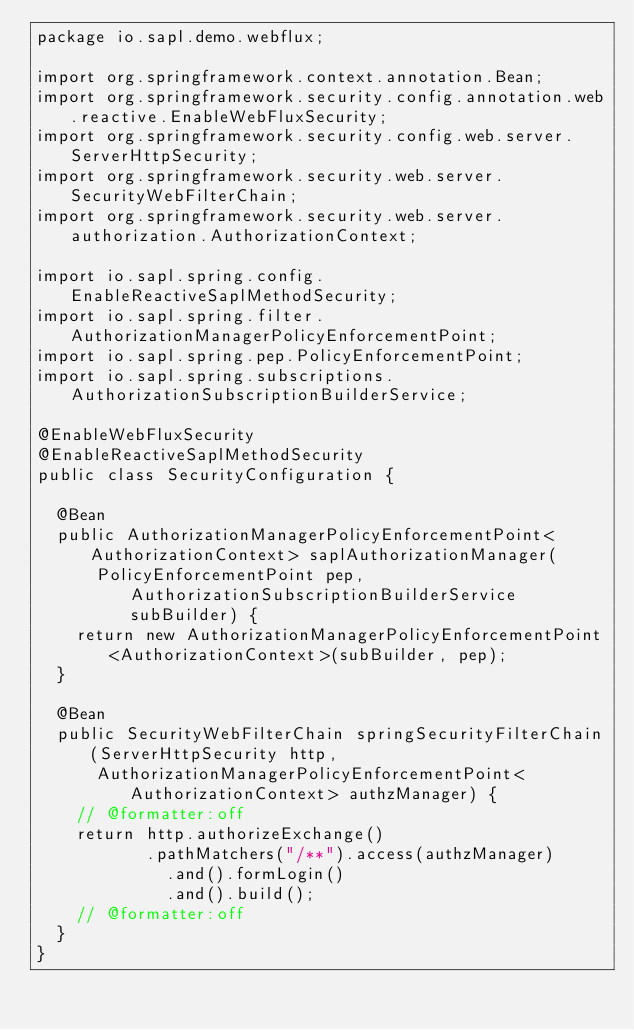<code> <loc_0><loc_0><loc_500><loc_500><_Java_>package io.sapl.demo.webflux;

import org.springframework.context.annotation.Bean;
import org.springframework.security.config.annotation.web.reactive.EnableWebFluxSecurity;
import org.springframework.security.config.web.server.ServerHttpSecurity;
import org.springframework.security.web.server.SecurityWebFilterChain;
import org.springframework.security.web.server.authorization.AuthorizationContext;

import io.sapl.spring.config.EnableReactiveSaplMethodSecurity;
import io.sapl.spring.filter.AuthorizationManagerPolicyEnforcementPoint;
import io.sapl.spring.pep.PolicyEnforcementPoint;
import io.sapl.spring.subscriptions.AuthorizationSubscriptionBuilderService;

@EnableWebFluxSecurity
@EnableReactiveSaplMethodSecurity
public class SecurityConfiguration {

	@Bean
	public AuthorizationManagerPolicyEnforcementPoint<AuthorizationContext> saplAuthorizationManager(
			PolicyEnforcementPoint pep, AuthorizationSubscriptionBuilderService subBuilder) {
		return new AuthorizationManagerPolicyEnforcementPoint<AuthorizationContext>(subBuilder, pep);
	}

	@Bean
	public SecurityWebFilterChain springSecurityFilterChain(ServerHttpSecurity http,
			AuthorizationManagerPolicyEnforcementPoint<AuthorizationContext> authzManager) {
		// @formatter:off
		return http.authorizeExchange()
				   .pathMatchers("/**").access(authzManager)
			       .and().formLogin()
			       .and().build();
		// @formatter:off
	}
}
</code> 